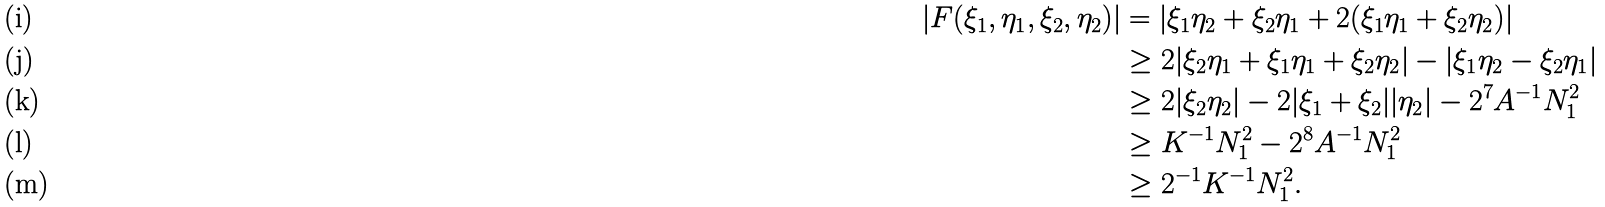<formula> <loc_0><loc_0><loc_500><loc_500>| F ( \xi _ { 1 } , \eta _ { 1 } , \xi _ { 2 } , \eta _ { 2 } ) | & = | \xi _ { 1 } \eta _ { 2 } + \xi _ { 2 } \eta _ { 1 } + 2 ( \xi _ { 1 } \eta _ { 1 } + \xi _ { 2 } \eta _ { 2 } ) | \\ & \geq 2 | \xi _ { 2 } \eta _ { 1 } + \xi _ { 1 } \eta _ { 1 } + \xi _ { 2 } \eta _ { 2 } | - | \xi _ { 1 } \eta _ { 2 } - \xi _ { 2 } \eta _ { 1 } | \\ & \geq 2 | \xi _ { 2 } \eta _ { 2 } | - 2 | \xi _ { 1 } + \xi _ { 2 } | | \eta _ { 2 } | - 2 ^ { 7 } A ^ { - 1 } N _ { 1 } ^ { 2 } \\ & \geq K ^ { - 1 } N _ { 1 } ^ { 2 } - 2 ^ { 8 } A ^ { - 1 } N _ { 1 } ^ { 2 } \\ & \geq 2 ^ { - 1 } K ^ { - 1 } N _ { 1 } ^ { 2 } .</formula> 